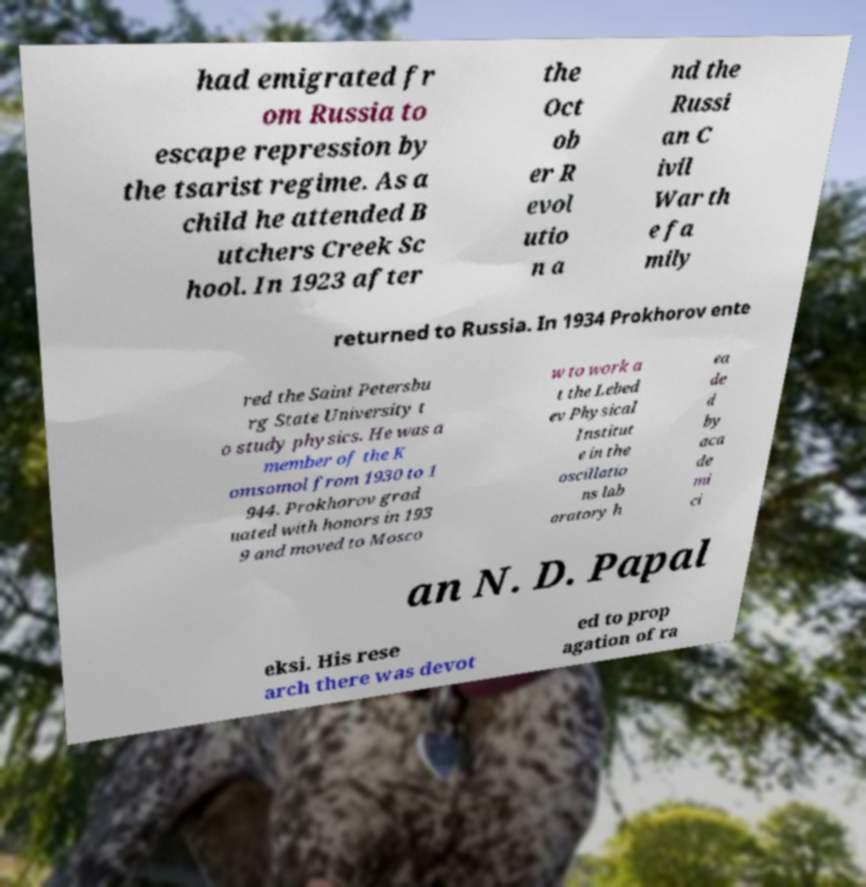Can you accurately transcribe the text from the provided image for me? had emigrated fr om Russia to escape repression by the tsarist regime. As a child he attended B utchers Creek Sc hool. In 1923 after the Oct ob er R evol utio n a nd the Russi an C ivil War th e fa mily returned to Russia. In 1934 Prokhorov ente red the Saint Petersbu rg State University t o study physics. He was a member of the K omsomol from 1930 to 1 944. Prokhorov grad uated with honors in 193 9 and moved to Mosco w to work a t the Lebed ev Physical Institut e in the oscillatio ns lab oratory h ea de d by aca de mi ci an N. D. Papal eksi. His rese arch there was devot ed to prop agation of ra 